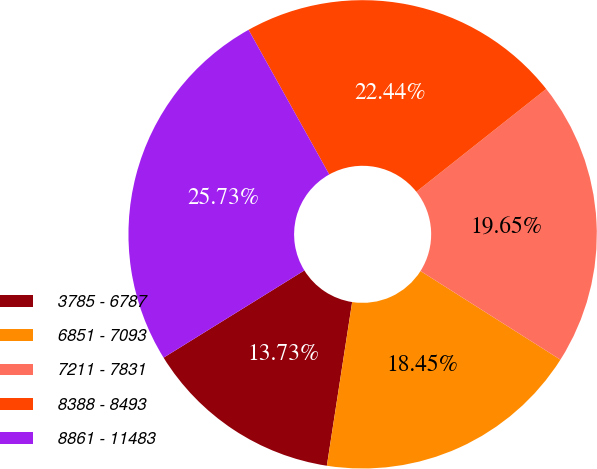Convert chart to OTSL. <chart><loc_0><loc_0><loc_500><loc_500><pie_chart><fcel>3785 - 6787<fcel>6851 - 7093<fcel>7211 - 7831<fcel>8388 - 8493<fcel>8861 - 11483<nl><fcel>13.73%<fcel>18.45%<fcel>19.65%<fcel>22.44%<fcel>25.73%<nl></chart> 